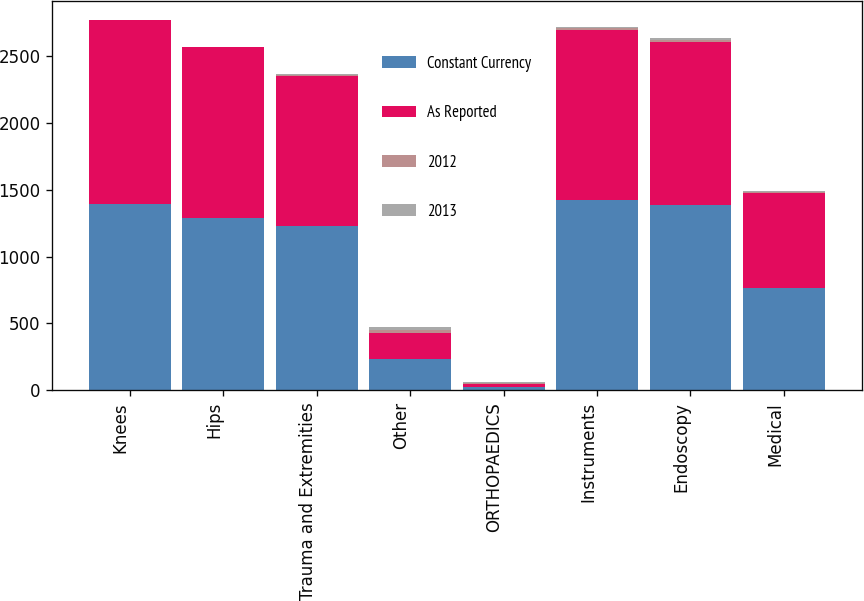Convert chart to OTSL. <chart><loc_0><loc_0><loc_500><loc_500><stacked_bar_chart><ecel><fcel>Knees<fcel>Hips<fcel>Trauma and Extremities<fcel>Other<fcel>ORTHOPAEDICS<fcel>Instruments<fcel>Endoscopy<fcel>Medical<nl><fcel>Constant Currency<fcel>1396<fcel>1291<fcel>1230<fcel>236<fcel>24.6<fcel>1424<fcel>1382<fcel>766<nl><fcel>As Reported<fcel>1371<fcel>1272<fcel>1116<fcel>190<fcel>24.6<fcel>1269<fcel>1222<fcel>710<nl><fcel>2012<fcel>1.8<fcel>1.5<fcel>10.2<fcel>24<fcel>5.2<fcel>12.2<fcel>13.1<fcel>7.9<nl><fcel>2013<fcel>2.7<fcel>2.7<fcel>11.4<fcel>25.2<fcel>6.3<fcel>13.1<fcel>14.2<fcel>8.8<nl></chart> 